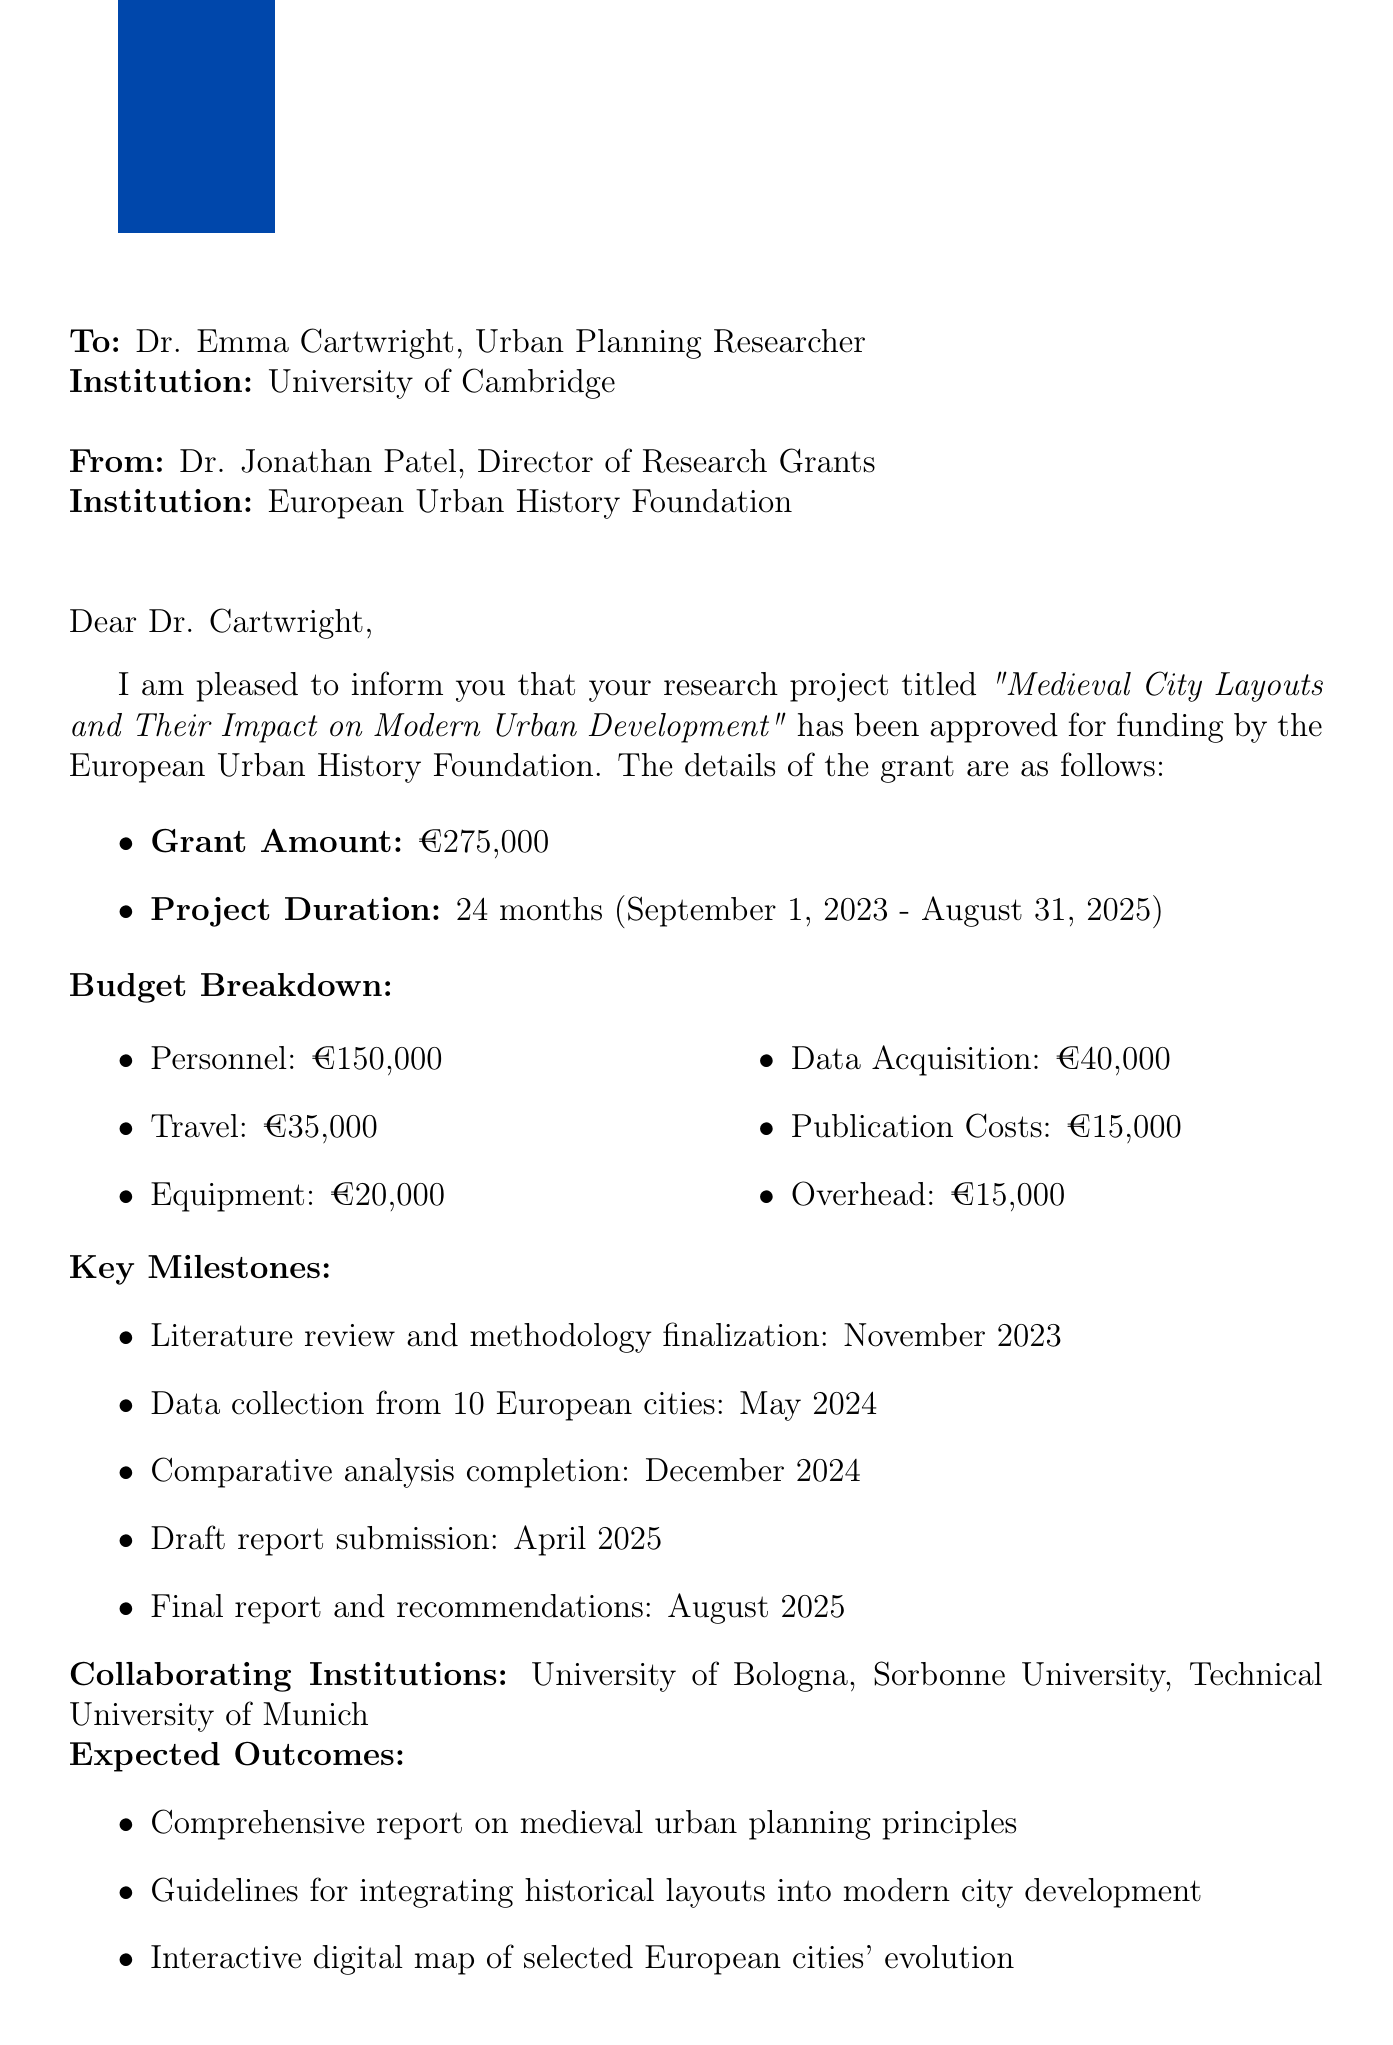What is the title of the project? The title of the project is explicitly mentioned in the document as "Medieval City Layouts and Their Impact on Modern Urban Development."
Answer: Medieval City Layouts and Their Impact on Modern Urban Development Who is the grant approval letter addressed to? The letter specifies that it is addressed to Dr. Emma Cartwright, Urban Planning Researcher, at the University of Cambridge.
Answer: Dr. Emma Cartwright What is the total grant amount approved? The document states the total grant amount approved is €275,000.
Answer: €275,000 What is the duration of the project? The document specifies the project duration as 24 months, starting from September 1, 2023, to August 31, 2025.
Answer: 24 months When is the literature review and methodology finalization scheduled to be completed? The key milestone for literature review and methodology finalization is noted as November 2023 in the document.
Answer: November 2023 Which institution is the chair of the approval committee from? The document indicates that the chair of the approval committee is Prof. Maria Sanchez, who is a member of an institution, but the specific institution is not mentioned.
Answer: Not mentioned What are the expected outcomes of the project? The document lists three expected outcomes, including a comprehensive report, guidelines for modern city development, and an interactive digital map.
Answer: Comprehensive report, guidelines, interactive digital map How many European cities will data be collected from? The project document states data will be collected from 10 European cities.
Answer: 10 European cities What is the publication cost in the budget breakdown? The budget breakdown in the document specifies the publication costs as €15,000.
Answer: €15,000 